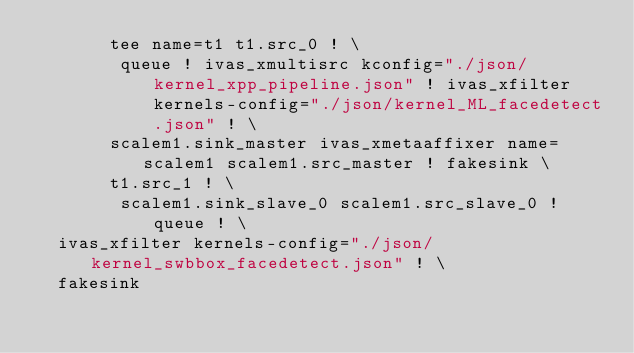Convert code to text. <code><loc_0><loc_0><loc_500><loc_500><_Bash_>       tee name=t1 t1.src_0 ! \
       	queue ! ivas_xmultisrc kconfig="./json/kernel_xpp_pipeline.json" ! ivas_xfilter kernels-config="./json/kernel_ML_facedetect.json" ! \
       scalem1.sink_master ivas_xmetaaffixer name=scalem1 scalem1.src_master ! fakesink \
       t1.src_1 ! \
       	scalem1.sink_slave_0 scalem1.src_slave_0 ! queue ! \
	ivas_xfilter kernels-config="./json/kernel_swbbox_facedetect.json" ! \
	fakesink</code> 